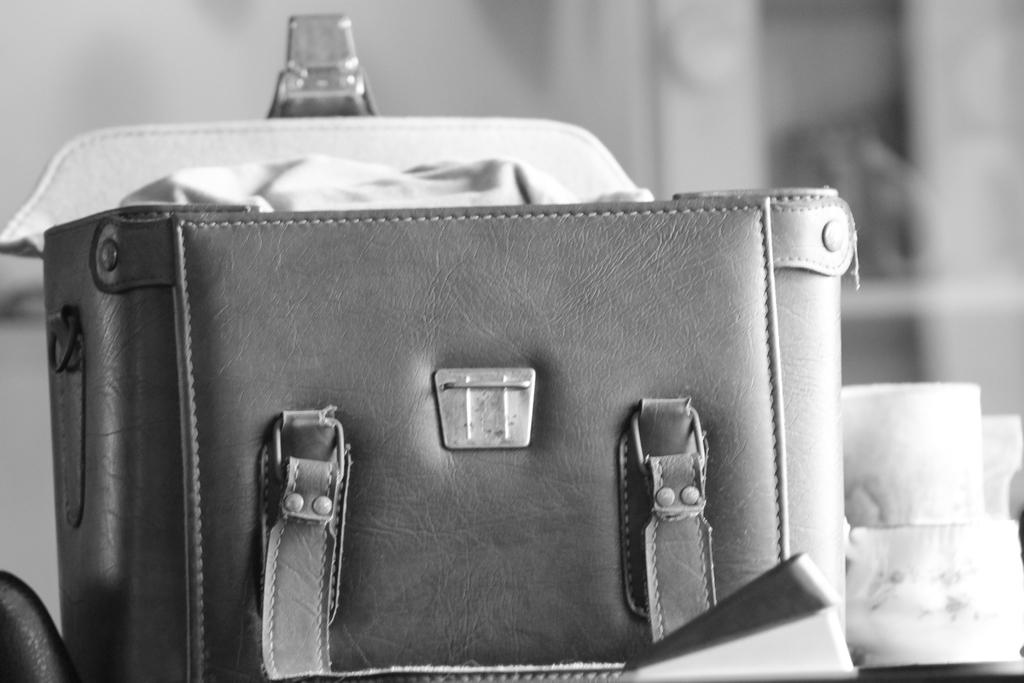What can be seen in the image? There is a bag in the image. What is located beside the bag? There is an unspecified object beside the bag. How is the bag positioned in the image? The bag is opened. How does the bag participate in the competition in the image? There is no competition present in the image, and therefore the bag cannot participate in any competition. 